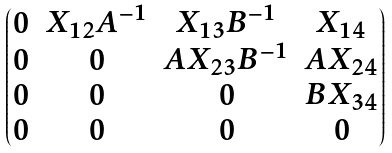Convert formula to latex. <formula><loc_0><loc_0><loc_500><loc_500>\begin{pmatrix} 0 & X _ { 1 2 } A ^ { - 1 } & X _ { 1 3 } B ^ { - 1 } & X _ { 1 4 } \\ 0 & 0 & A X _ { 2 3 } B ^ { - 1 } & A X _ { 2 4 } \\ 0 & 0 & 0 & B X _ { 3 4 } \\ 0 & 0 & 0 & 0 \\ \end{pmatrix}</formula> 